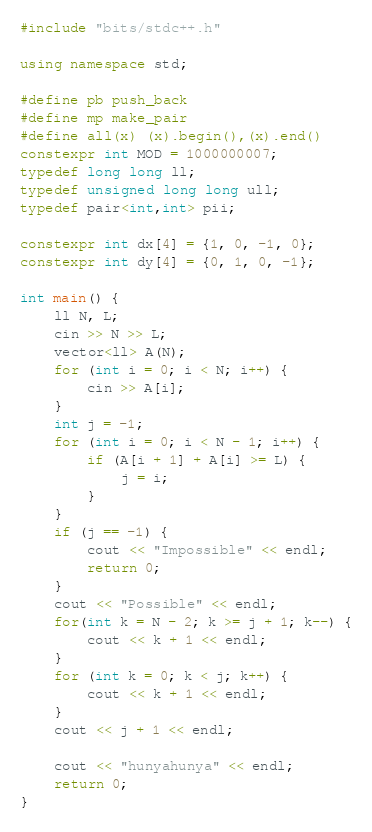<code> <loc_0><loc_0><loc_500><loc_500><_C++_>#include "bits/stdc++.h"

using namespace std;

#define pb push_back
#define mp make_pair
#define all(x) (x).begin(),(x).end()
constexpr int MOD = 1000000007;
typedef long long ll;
typedef unsigned long long ull;
typedef pair<int,int> pii;

constexpr int dx[4] = {1, 0, -1, 0};
constexpr int dy[4] = {0, 1, 0, -1};

int main() {
    ll N, L;
    cin >> N >> L;
    vector<ll> A(N);
    for (int i = 0; i < N; i++) {
        cin >> A[i];
    }
    int j = -1;
    for (int i = 0; i < N - 1; i++) {
        if (A[i + 1] + A[i] >= L) {
            j = i;
        }
    }
    if (j == -1) {
        cout << "Impossible" << endl;
        return 0;
    }
    cout << "Possible" << endl;
    for(int k = N - 2; k >= j + 1; k--) {
        cout << k + 1 << endl;
    }
    for (int k = 0; k < j; k++) {
        cout << k + 1 << endl;
    }
    cout << j + 1 << endl;

    cout << "hunyahunya" << endl;
    return 0;
}
</code> 